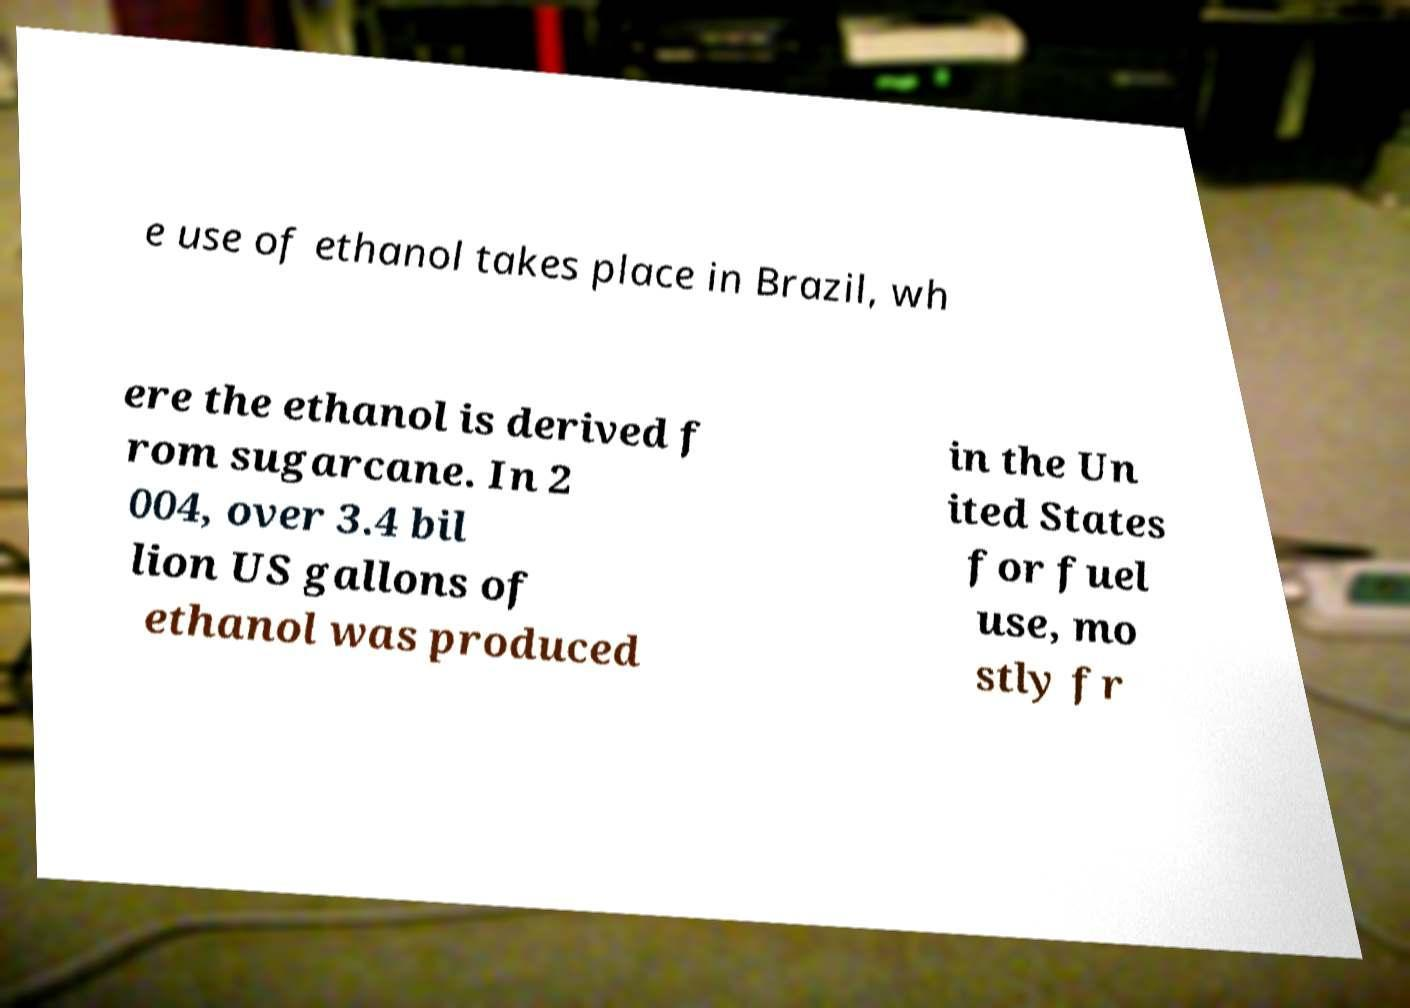Can you accurately transcribe the text from the provided image for me? e use of ethanol takes place in Brazil, wh ere the ethanol is derived f rom sugarcane. In 2 004, over 3.4 bil lion US gallons of ethanol was produced in the Un ited States for fuel use, mo stly fr 